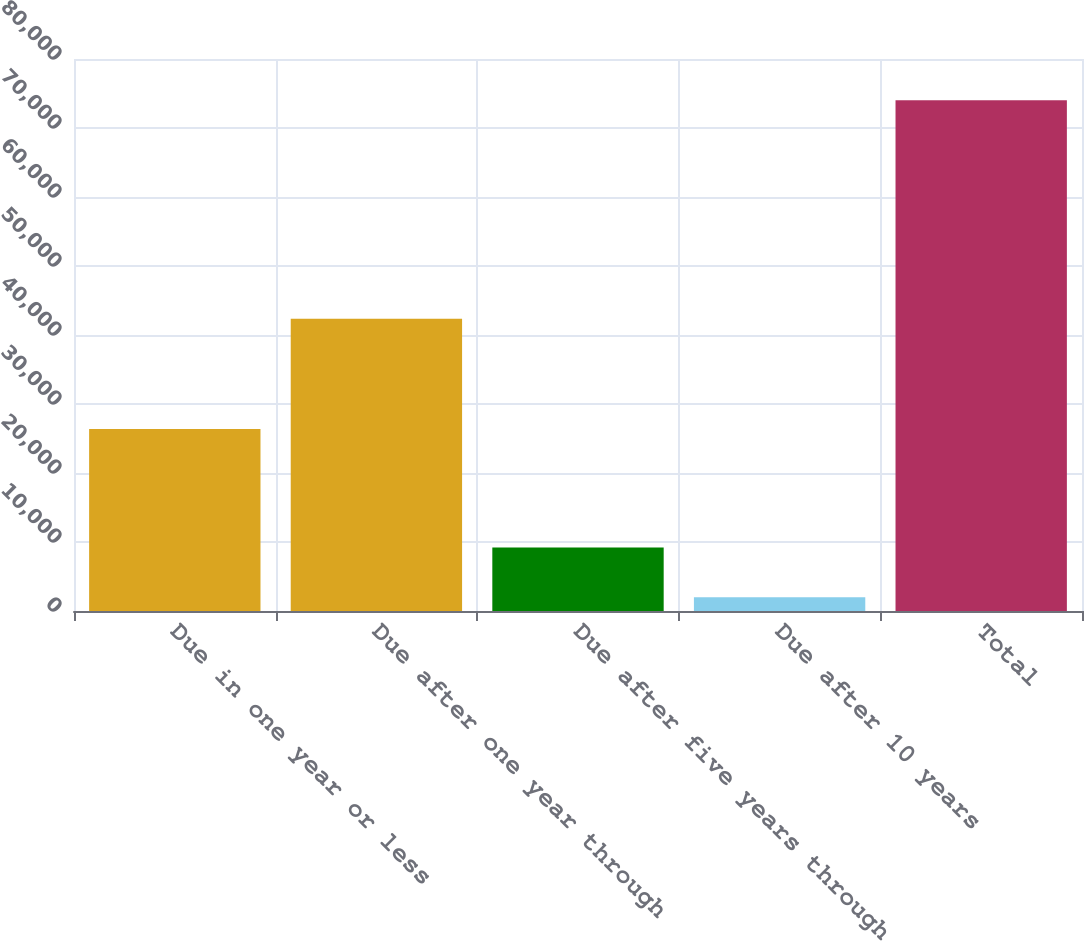<chart> <loc_0><loc_0><loc_500><loc_500><bar_chart><fcel>Due in one year or less<fcel>Due after one year through<fcel>Due after five years through<fcel>Due after 10 years<fcel>Total<nl><fcel>26386<fcel>42343<fcel>9212.2<fcel>2010<fcel>74032<nl></chart> 